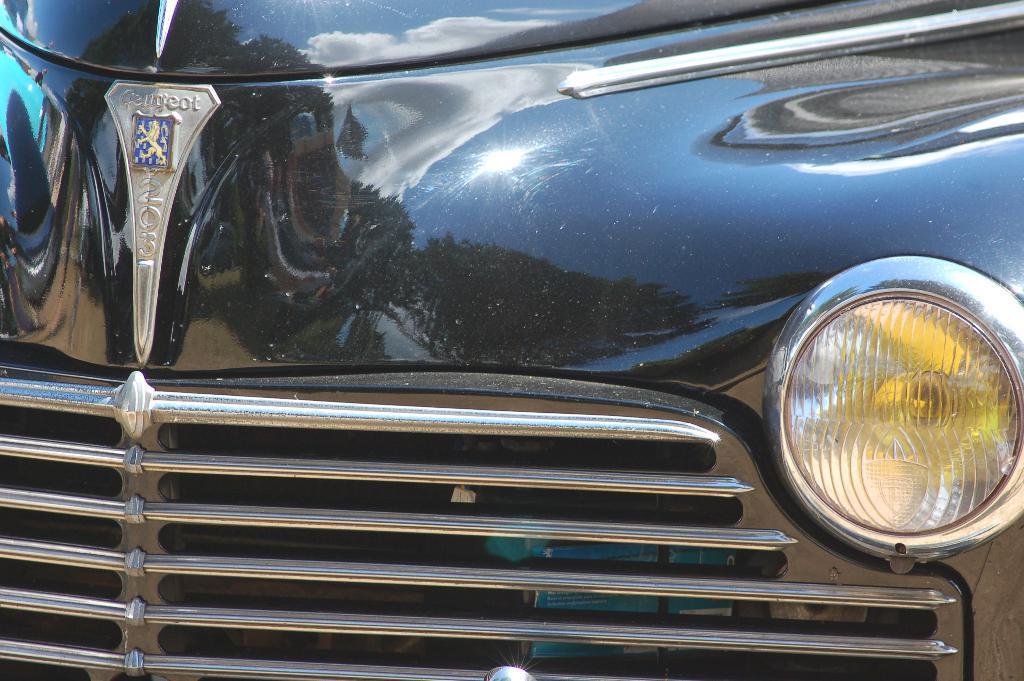Can you describe this image briefly? In the image we can see a bumper and headlight of a vehicle. 